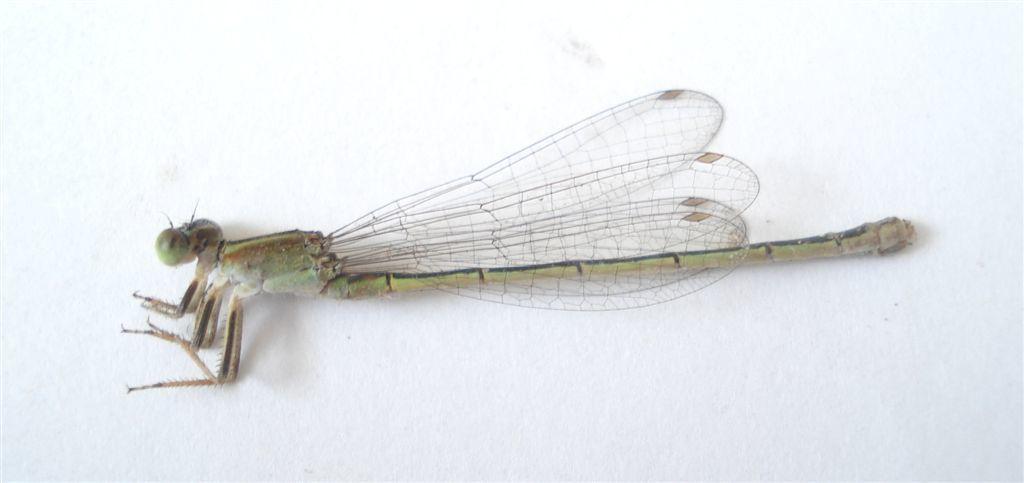Please provide a concise description of this image. In this image we can see a dragonfly. 